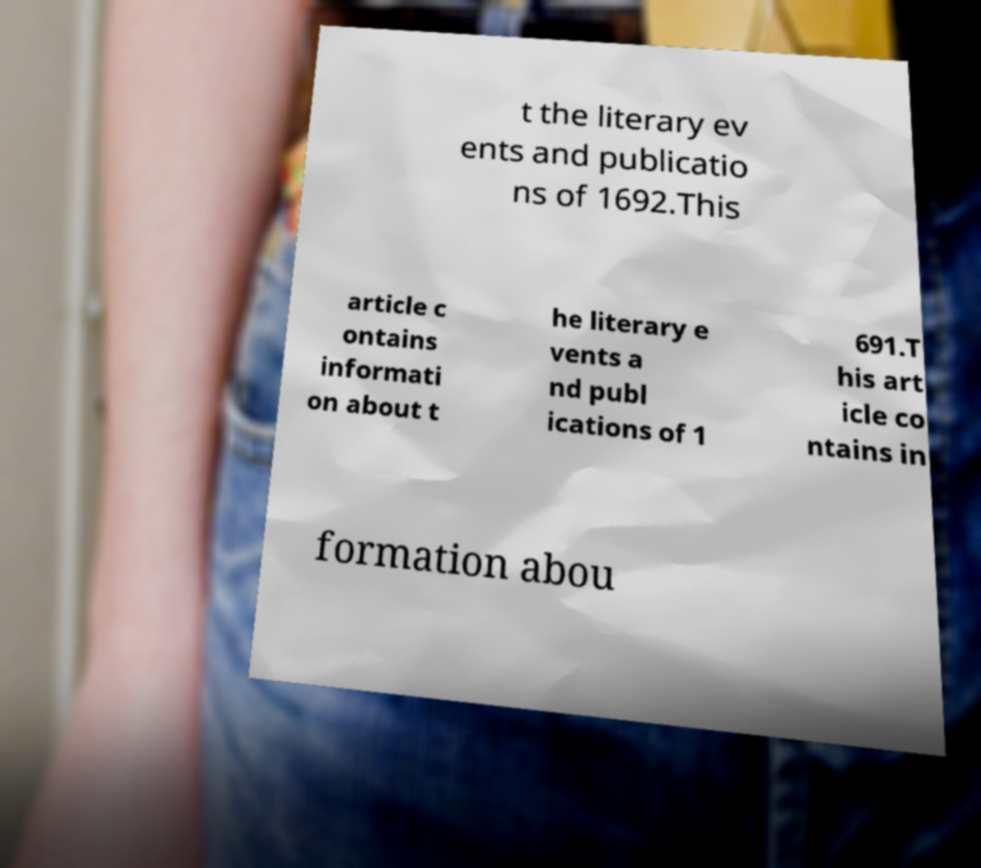I need the written content from this picture converted into text. Can you do that? t the literary ev ents and publicatio ns of 1692.This article c ontains informati on about t he literary e vents a nd publ ications of 1 691.T his art icle co ntains in formation abou 